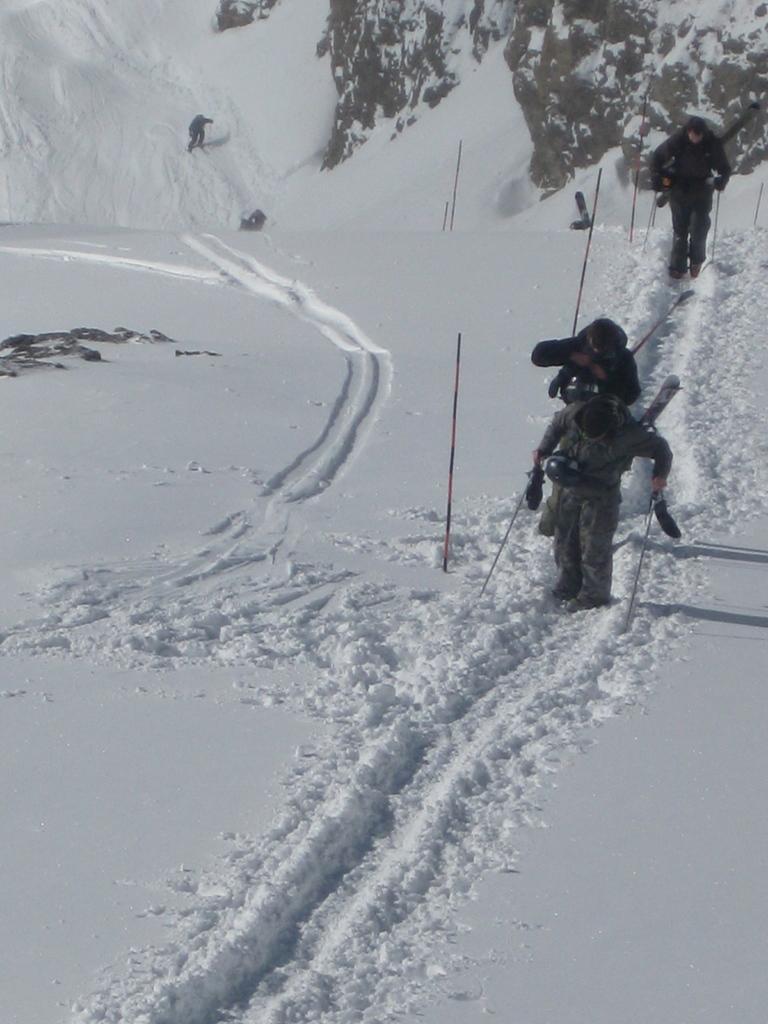Please provide a concise description of this image. This picture describes about group of people, they are walking in the snow, and they are holding sticks. 